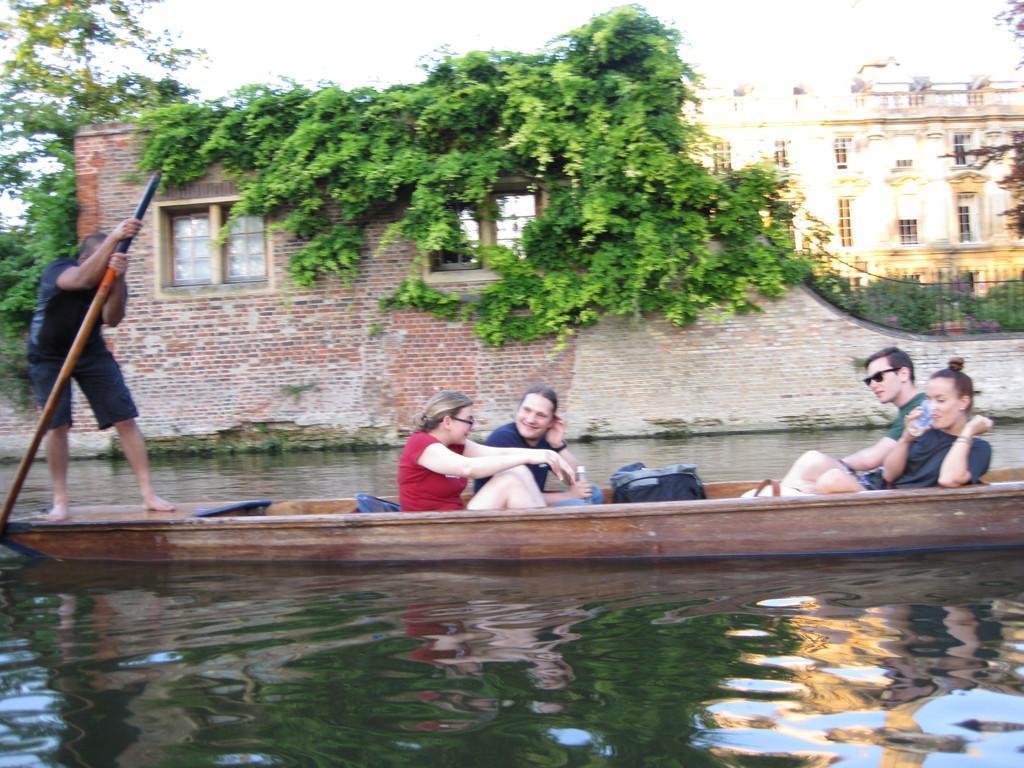Can you describe this image briefly? In the middle, we see five people are riding the boat. At the bottom, we see water and this water might be in the canal. Behind them, we see a building which is made up of bricks. It has the glass windows. There are trees, iron railing and a building in the background. At the top, we see the sky. 